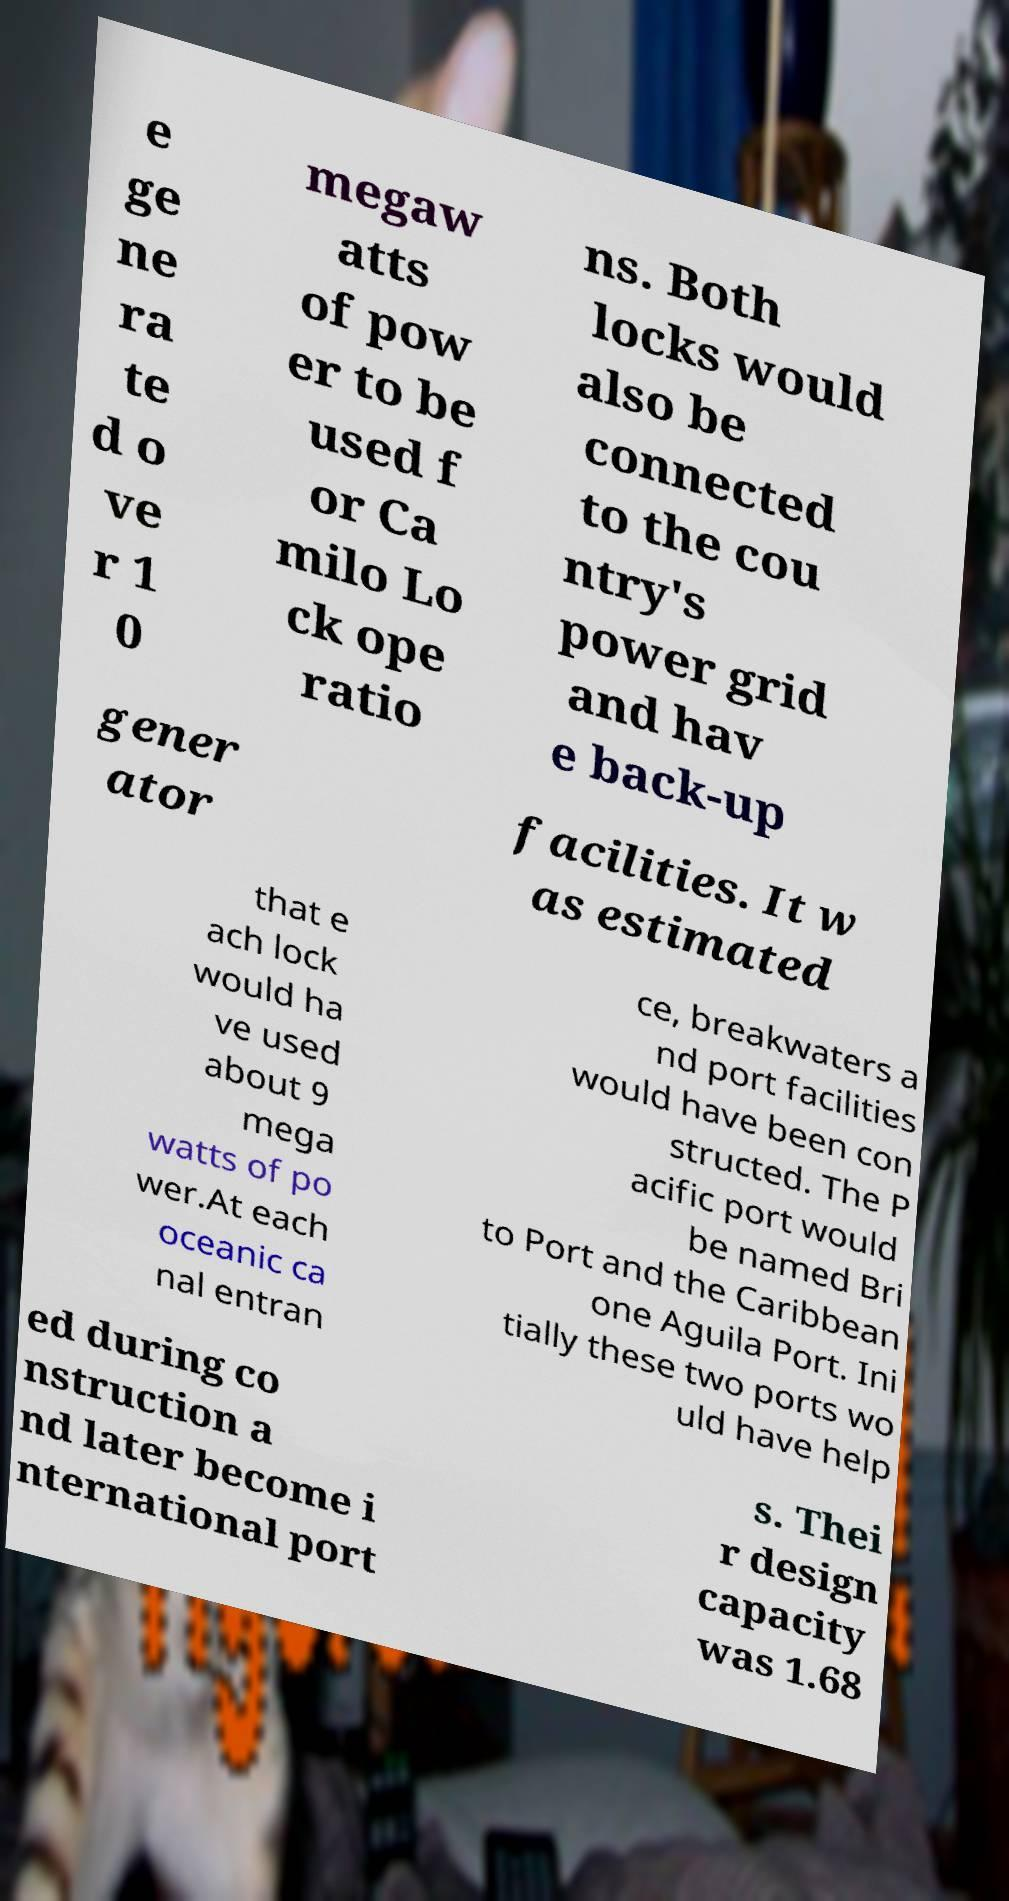Could you assist in decoding the text presented in this image and type it out clearly? e ge ne ra te d o ve r 1 0 megaw atts of pow er to be used f or Ca milo Lo ck ope ratio ns. Both locks would also be connected to the cou ntry's power grid and hav e back-up gener ator facilities. It w as estimated that e ach lock would ha ve used about 9 mega watts of po wer.At each oceanic ca nal entran ce, breakwaters a nd port facilities would have been con structed. The P acific port would be named Bri to Port and the Caribbean one Aguila Port. Ini tially these two ports wo uld have help ed during co nstruction a nd later become i nternational port s. Thei r design capacity was 1.68 